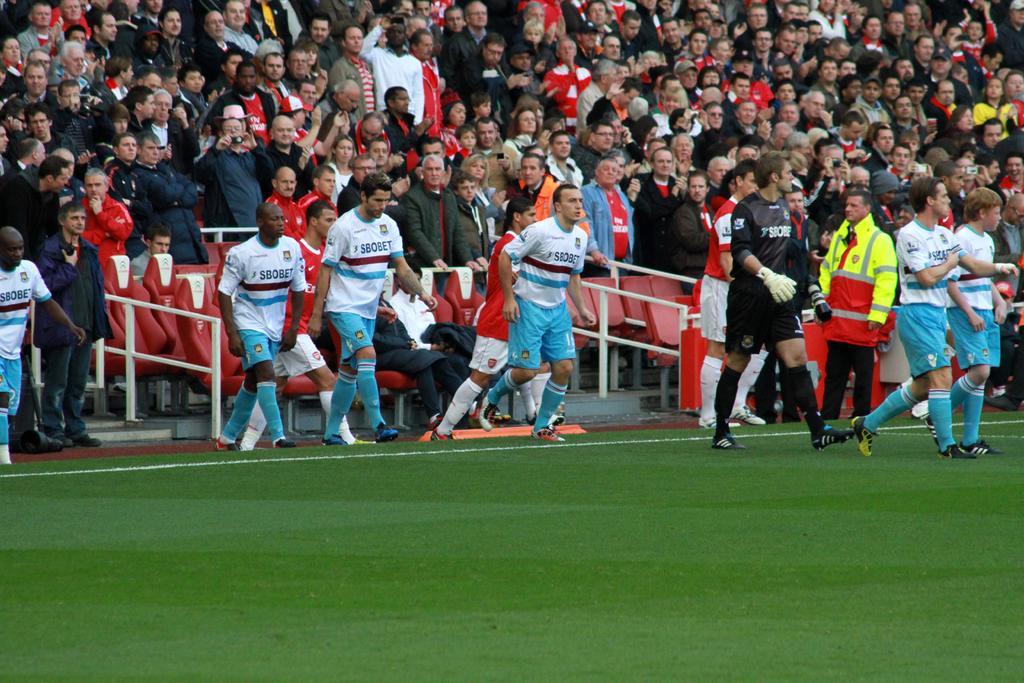Describe this image in one or two sentences. In this image we can see some people standing on the grass field. In the background, we can see group of audience, chairs and some barricades. 